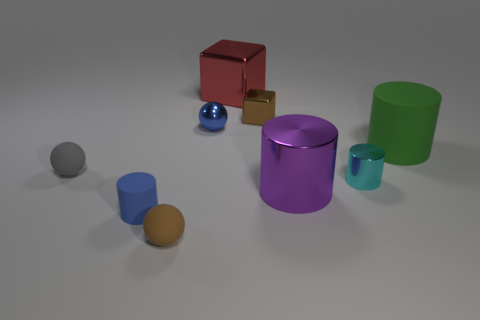Which object seems the heaviest and why? The red cube looks to be the heaviest object due to its size and the way it reflects light, indicating that it could be made of a dense material such as metal. However, without knowing the actual composition and the volume of the interior, this is a visual estimation. 